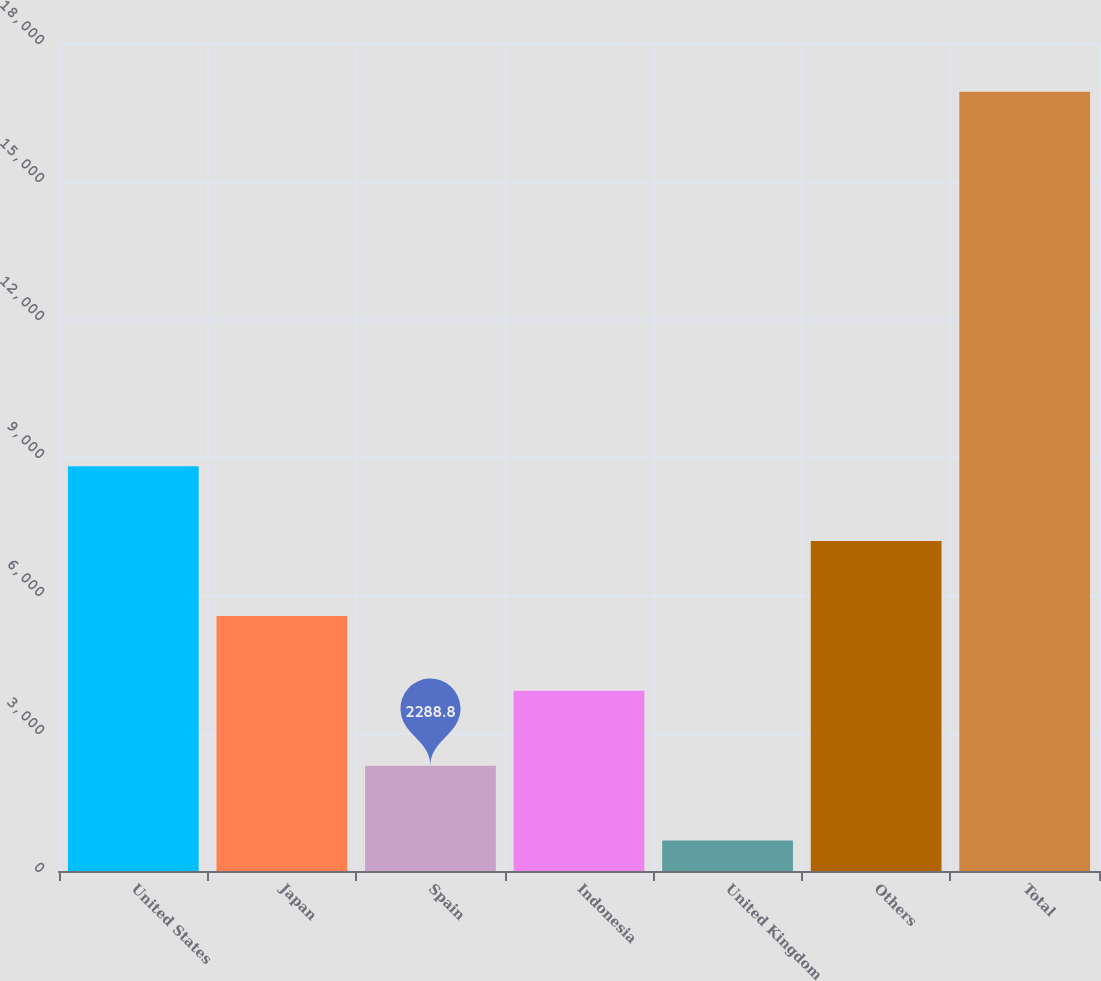Convert chart. <chart><loc_0><loc_0><loc_500><loc_500><bar_chart><fcel>United States<fcel>Japan<fcel>Spain<fcel>Indonesia<fcel>United Kingdom<fcel>Others<fcel>Total<nl><fcel>8800<fcel>5544.4<fcel>2288.8<fcel>3916.6<fcel>661<fcel>7172.2<fcel>16939<nl></chart> 